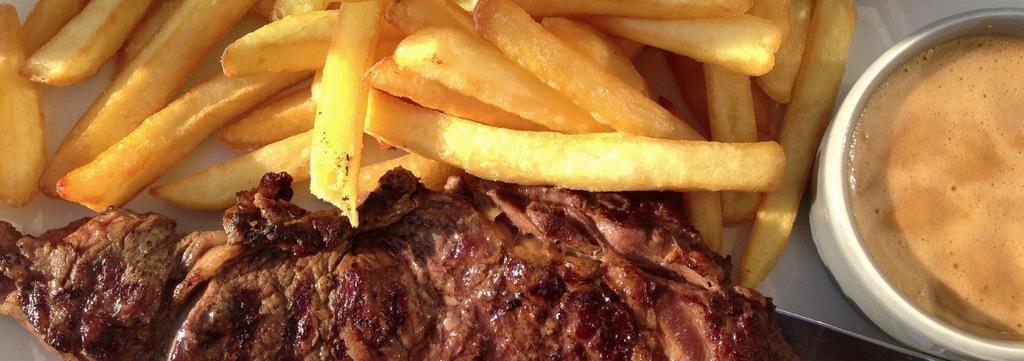Can you describe this image briefly? In this image on the right side, I can see a cup. I can also see some food item on the plate. 